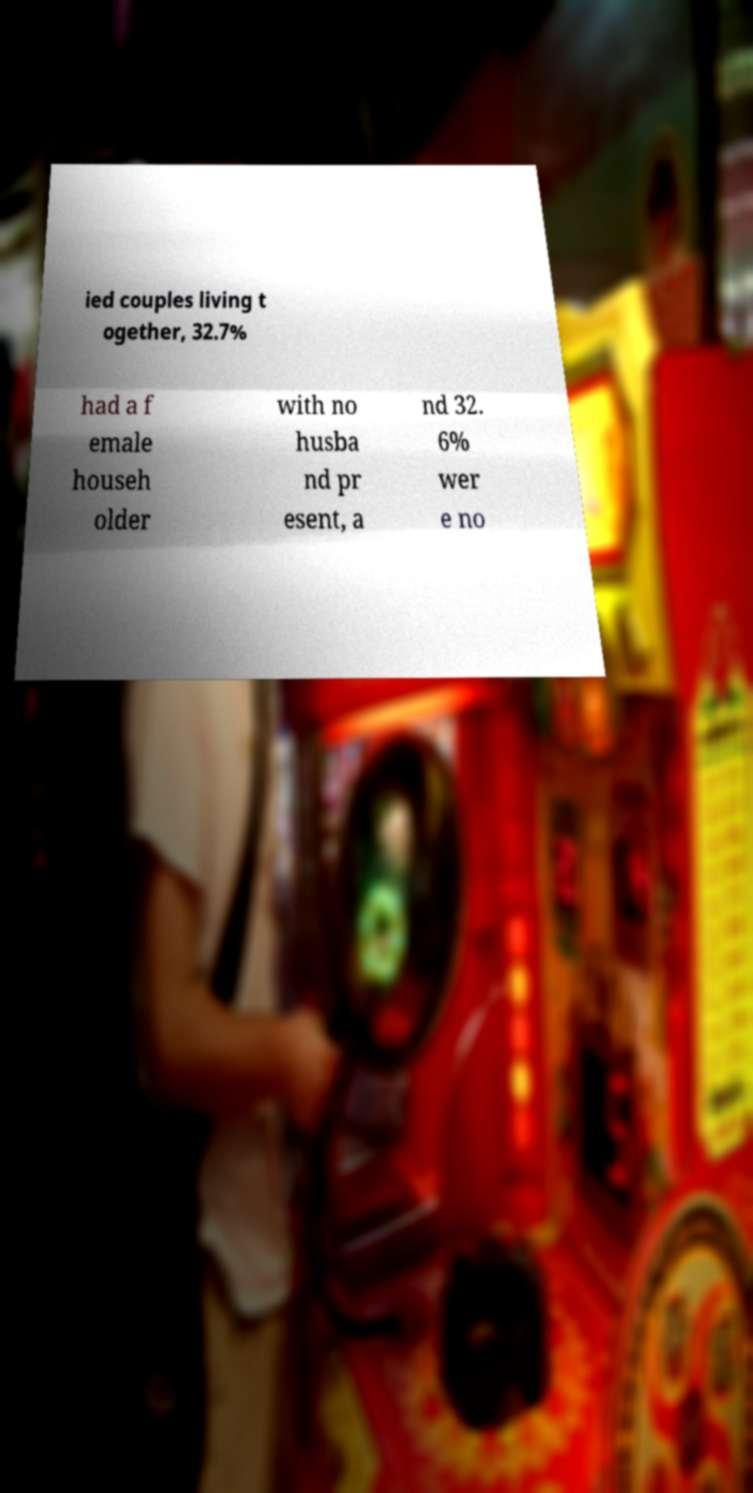I need the written content from this picture converted into text. Can you do that? ied couples living t ogether, 32.7% had a f emale househ older with no husba nd pr esent, a nd 32. 6% wer e no 